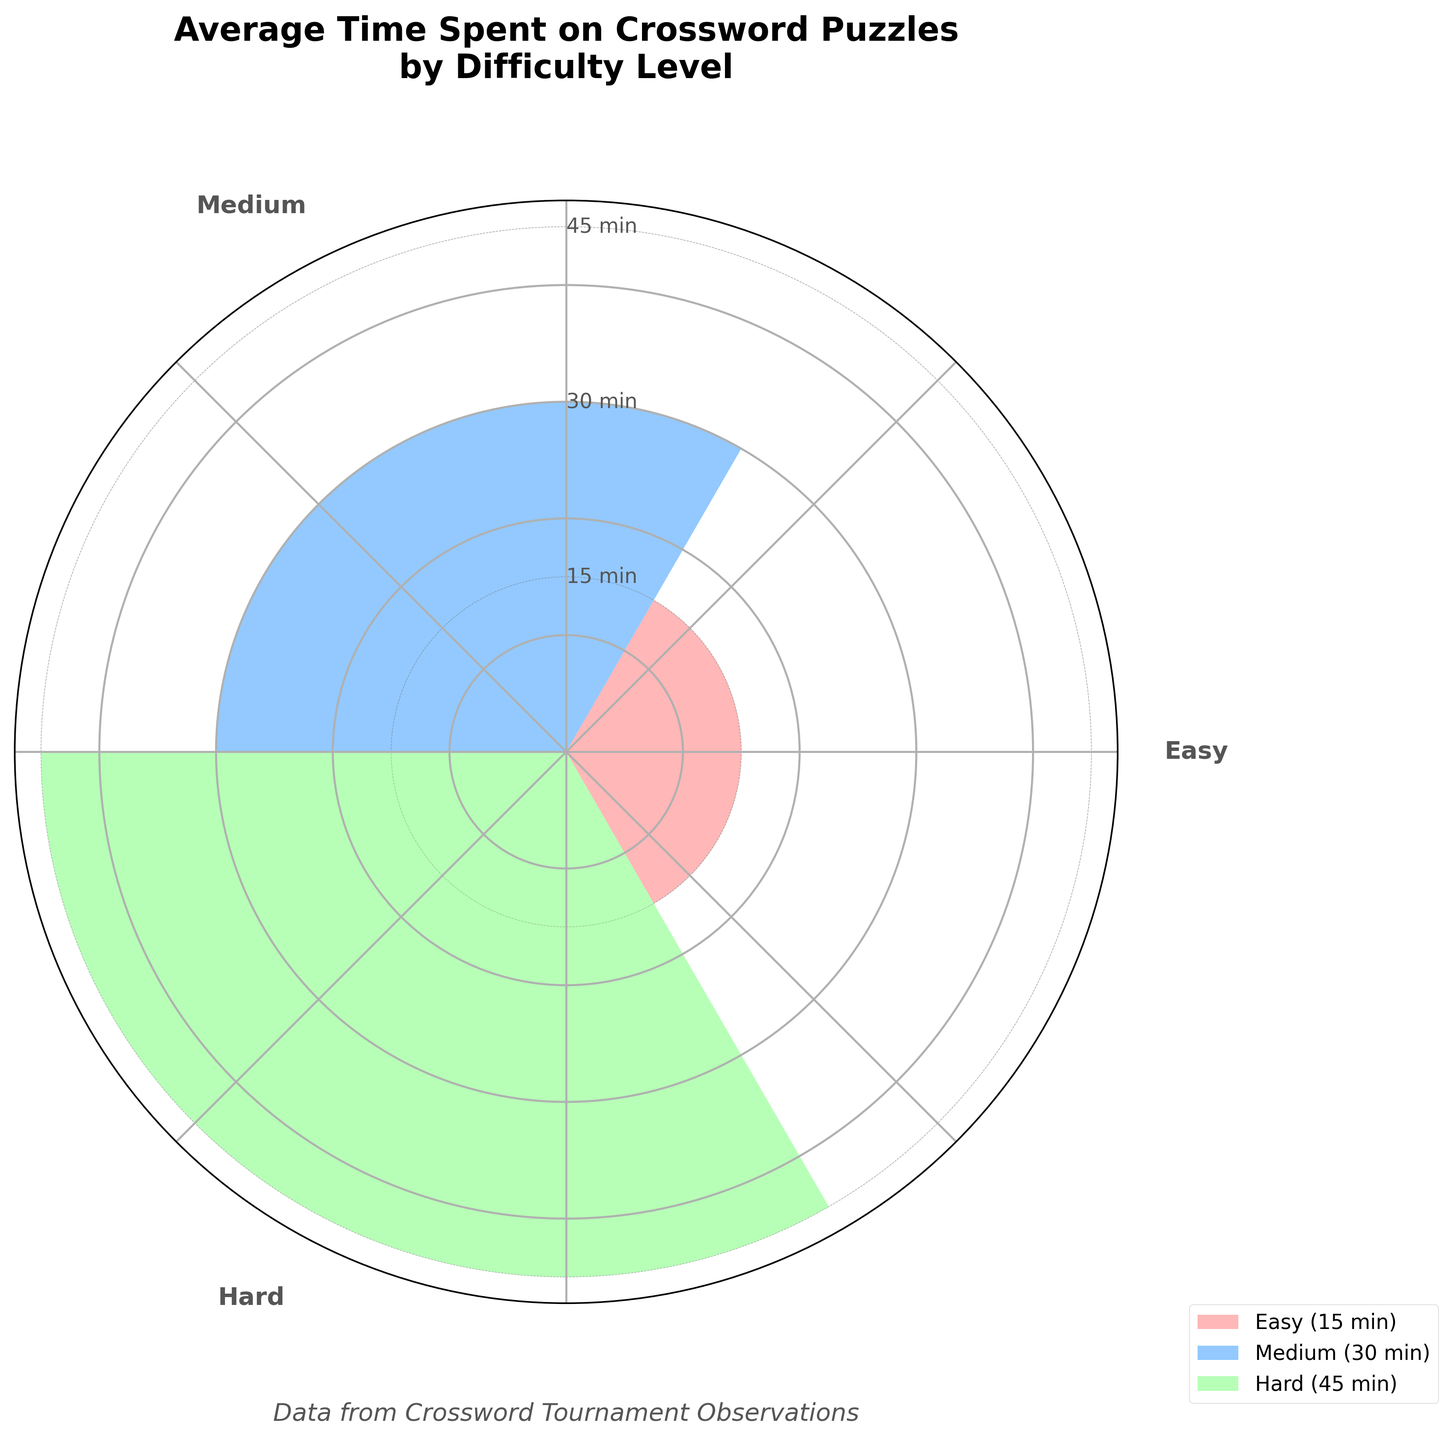What is the average time spent on easy crossword puzzles per tournament? According to the rose chart, the specific portion for easy crossword puzzles is highlighted, showing that the average time spent on them is 15 minutes.
Answer: 15 minutes What is the title of the figure? The title of the figure, typically found at the top of the chart, reads "Average Time Spent on Crossword Puzzles by Difficulty Level".
Answer: Average Time Spent on Crossword Puzzles by Difficulty Level Which difficulty level has the longest average time spent on crossword puzzles per tournament? By observing the chart, the difficulty level with the longest bar/radius is identified as "Hard", which is associated with 45 minutes.
Answer: Hard How does the average time spent on medium crossword puzzles compare to easy ones? From the chart, we see that the medium puzzles have an average time of 30 minutes, whereas easy puzzles have 15 minutes. By comparing these values, we notice that medium puzzles take twice as long as easy ones.
Answer: Twice as long What is the sum of the average times spent on easy, medium, and hard crossword puzzles per tournament? Adding the times indicated in the rose chart: Easy (15) + Medium (30) + Hard (45) = 90 minutes in total.
Answer: 90 minutes Which difficulty level is positioned immediately after easy crossword puzzles in the rose chart? The chart arranges the difficulty levels in sequence, and immediately following the "Easy" level (15 minutes) is the "Medium" level (30 minutes).
Answer: Medium List the difficulty levels represented in the rose chart. The difficulty levels are labeled around the chart, and they include Easy, Medium, and Hard.
Answer: Easy, Medium, Hard 